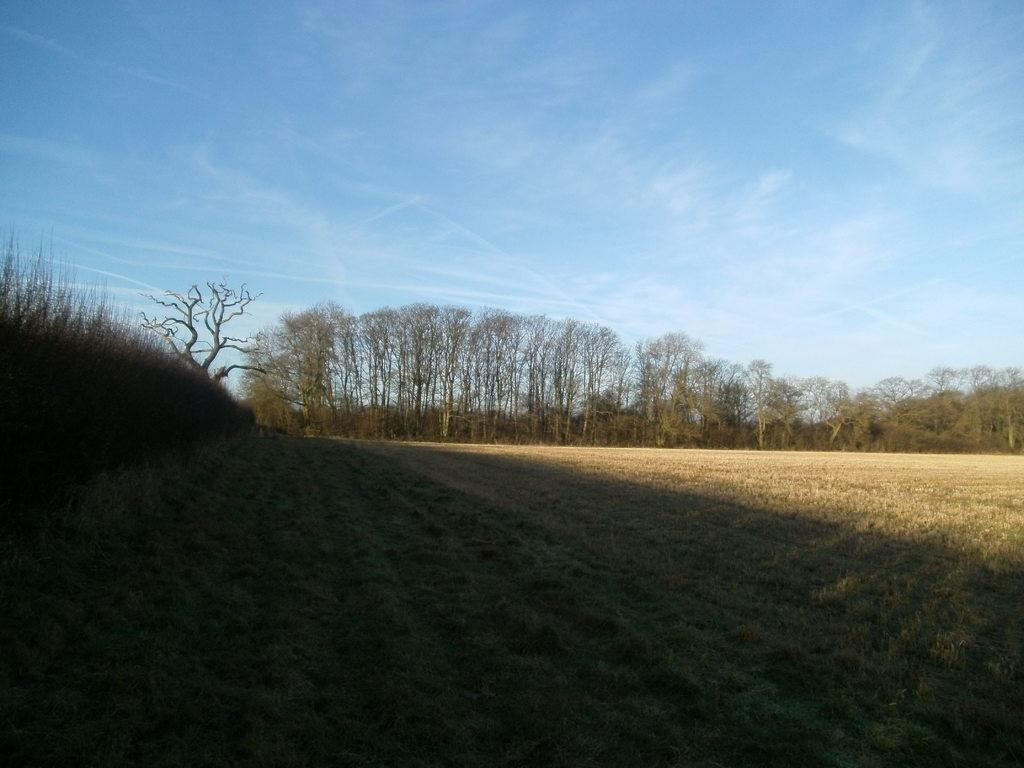Describe this image in one or two sentences. In this image I can see the ground, some grass on the ground and few trees. In the background I can see the sky. 